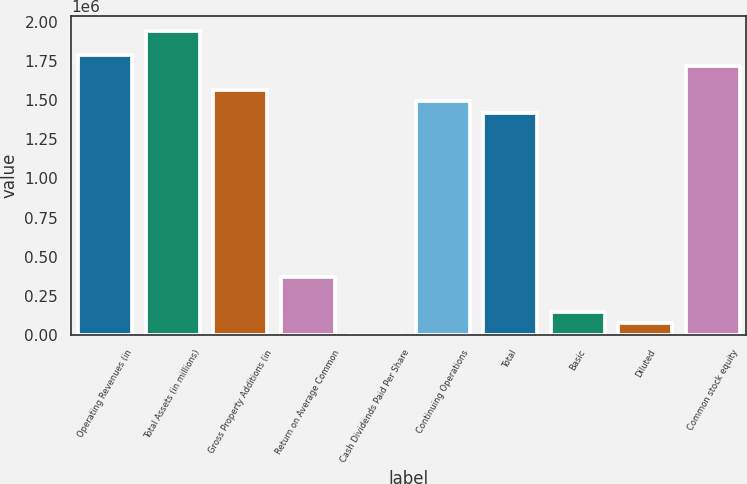<chart> <loc_0><loc_0><loc_500><loc_500><bar_chart><fcel>Operating Revenues (in<fcel>Total Assets (in millions)<fcel>Gross Property Additions (in<fcel>Return on Average Common<fcel>Cash Dividends Paid Per Share<fcel>Continuing Operations<fcel>Total<fcel>Basic<fcel>Diluted<fcel>Common stock equity<nl><fcel>1.79105e+06<fcel>1.9403e+06<fcel>1.56717e+06<fcel>373136<fcel>1.53<fcel>1.49254e+06<fcel>1.41791e+06<fcel>149255<fcel>74628.4<fcel>1.71642e+06<nl></chart> 